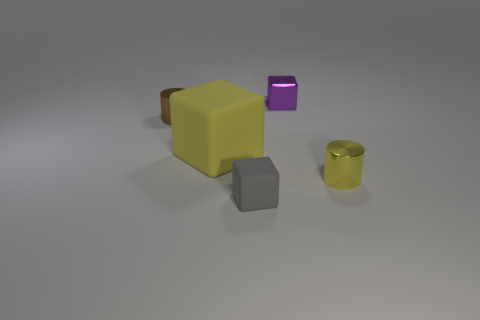What material is the yellow object left of the shiny cylinder on the right side of the tiny purple block made of? The yellow object, which appears to the left of the shiny cylinder and on the right side of the tiny purple block, resembles a sponge due to its texture and porous surface. While I identified it as being made of rubber in the initial response, upon closer examination, the material could also be foam or a similar synthetic material designed to mimic the characteristics of a sponge. 